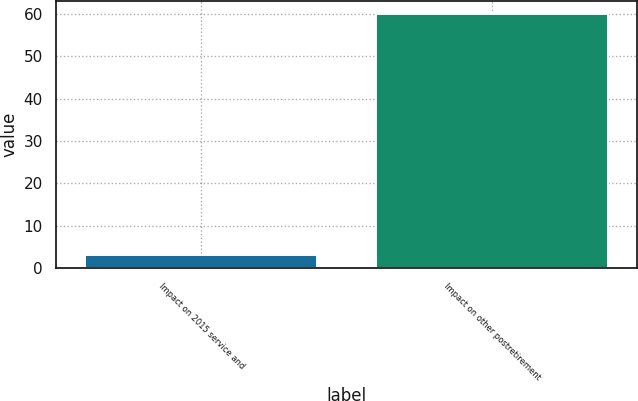Convert chart. <chart><loc_0><loc_0><loc_500><loc_500><bar_chart><fcel>Impact on 2015 service and<fcel>Impact on other postretirement<nl><fcel>3<fcel>60<nl></chart> 